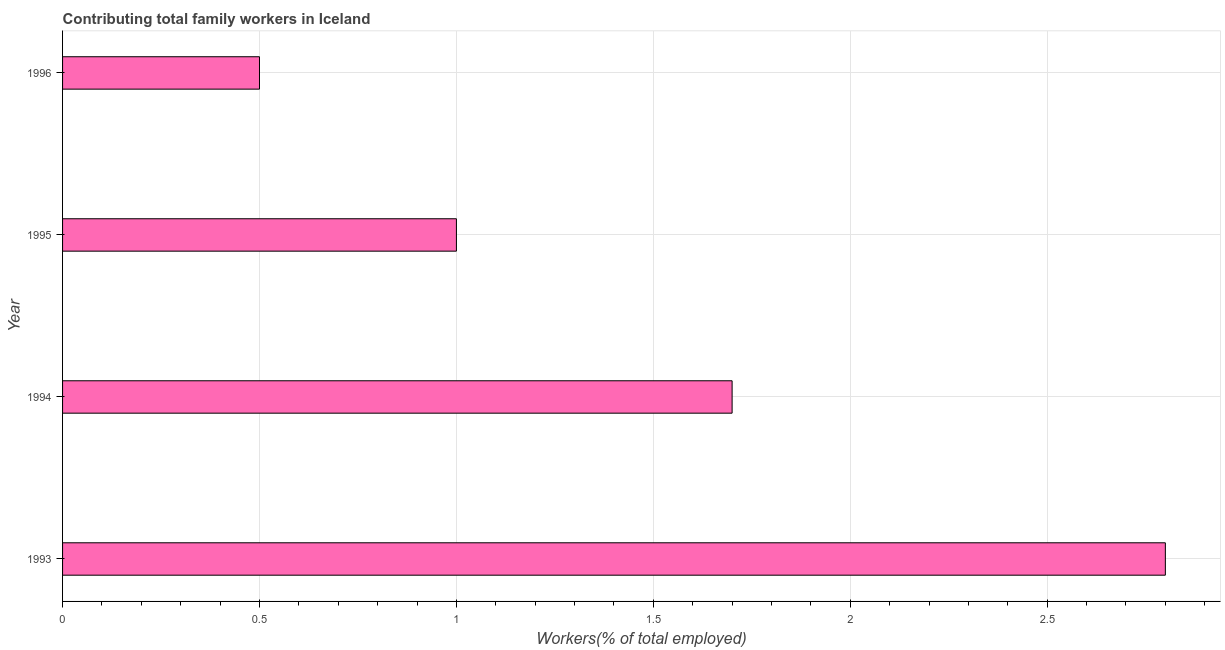What is the title of the graph?
Ensure brevity in your answer.  Contributing total family workers in Iceland. What is the label or title of the X-axis?
Offer a terse response. Workers(% of total employed). What is the contributing family workers in 1995?
Keep it short and to the point. 1. Across all years, what is the maximum contributing family workers?
Ensure brevity in your answer.  2.8. In which year was the contributing family workers maximum?
Your answer should be very brief. 1993. What is the difference between the contributing family workers in 1994 and 1995?
Ensure brevity in your answer.  0.7. What is the average contributing family workers per year?
Offer a very short reply. 1.5. What is the median contributing family workers?
Provide a short and direct response. 1.35. Is the contributing family workers in 1994 less than that in 1996?
Provide a short and direct response. No. Is the difference between the contributing family workers in 1995 and 1996 greater than the difference between any two years?
Offer a terse response. No. What is the difference between the highest and the second highest contributing family workers?
Provide a short and direct response. 1.1. What is the difference between the highest and the lowest contributing family workers?
Provide a short and direct response. 2.3. In how many years, is the contributing family workers greater than the average contributing family workers taken over all years?
Ensure brevity in your answer.  2. How many bars are there?
Keep it short and to the point. 4. Are all the bars in the graph horizontal?
Make the answer very short. Yes. What is the Workers(% of total employed) in 1993?
Your answer should be compact. 2.8. What is the Workers(% of total employed) in 1994?
Keep it short and to the point. 1.7. What is the difference between the Workers(% of total employed) in 1993 and 1994?
Your response must be concise. 1.1. What is the difference between the Workers(% of total employed) in 1993 and 1995?
Your answer should be compact. 1.8. What is the difference between the Workers(% of total employed) in 1994 and 1995?
Provide a succinct answer. 0.7. What is the difference between the Workers(% of total employed) in 1994 and 1996?
Offer a terse response. 1.2. What is the ratio of the Workers(% of total employed) in 1993 to that in 1994?
Your answer should be compact. 1.65. What is the ratio of the Workers(% of total employed) in 1993 to that in 1995?
Provide a short and direct response. 2.8. What is the ratio of the Workers(% of total employed) in 1994 to that in 1996?
Keep it short and to the point. 3.4. What is the ratio of the Workers(% of total employed) in 1995 to that in 1996?
Your response must be concise. 2. 